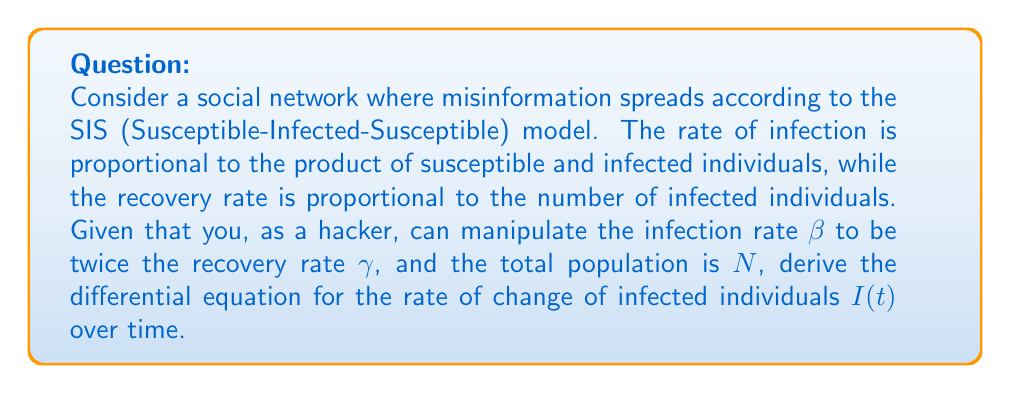Teach me how to tackle this problem. 1. In the SIS model, we have two compartments: Susceptible (S) and Infected (I).

2. The total population N is constant: $N = S + I$

3. The rate of change of infected individuals is given by:
   $$\frac{dI}{dt} = \text{new infections} - \text{recoveries}$$

4. New infections occur at rate βSI/N, where β is the infection rate:
   $\text{new infections} = \beta \frac{SI}{N}$

5. Recoveries occur at rate γI, where γ is the recovery rate:
   $\text{recoveries} = \gamma I$

6. Given that β = 2γ, we can substitute this into our equation:
   $$\frac{dI}{dt} = 2\gamma \frac{SI}{N} - \gamma I$$

7. We know that S = N - I, so we can substitute this:
   $$\frac{dI}{dt} = 2\gamma \frac{(N-I)I}{N} - \gamma I$$

8. Simplifying:
   $$\frac{dI}{dt} = 2\gamma I - 2\gamma \frac{I^2}{N} - \gamma I$$
   $$\frac{dI}{dt} = \gamma I - 2\gamma \frac{I^2}{N}$$

This is the final differential equation describing the rate of change of infected individuals over time.
Answer: $$\frac{dI}{dt} = \gamma I - 2\gamma \frac{I^2}{N}$$ 